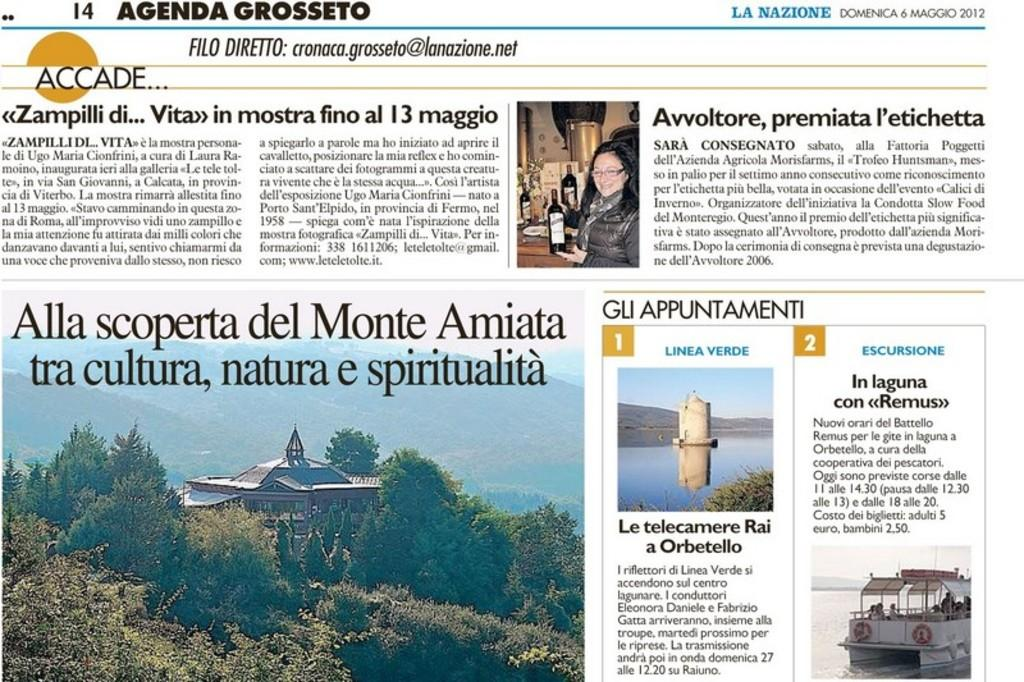<image>
Describe the image concisely. A newspaper page says "agenda grosseto" at the top. 